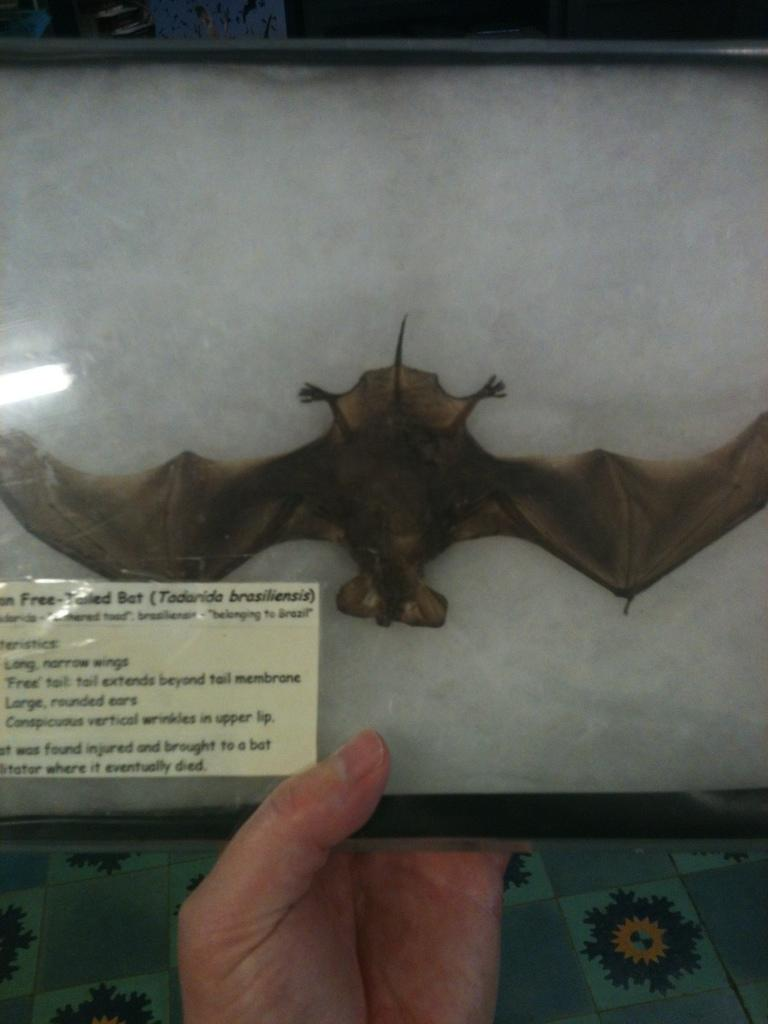Where was the image taken? The image was taken indoors. What can be seen at the bottom of the image? There is a floor visible at the bottom of the image. What is the person's hand holding in the image? The person's hand is holding a box. What is inside the box? The box contains a bat and a paper with text. What type of current can be seen flowing through the bat in the image? There is no current visible in the image; it is a static image of a bat inside a box. 